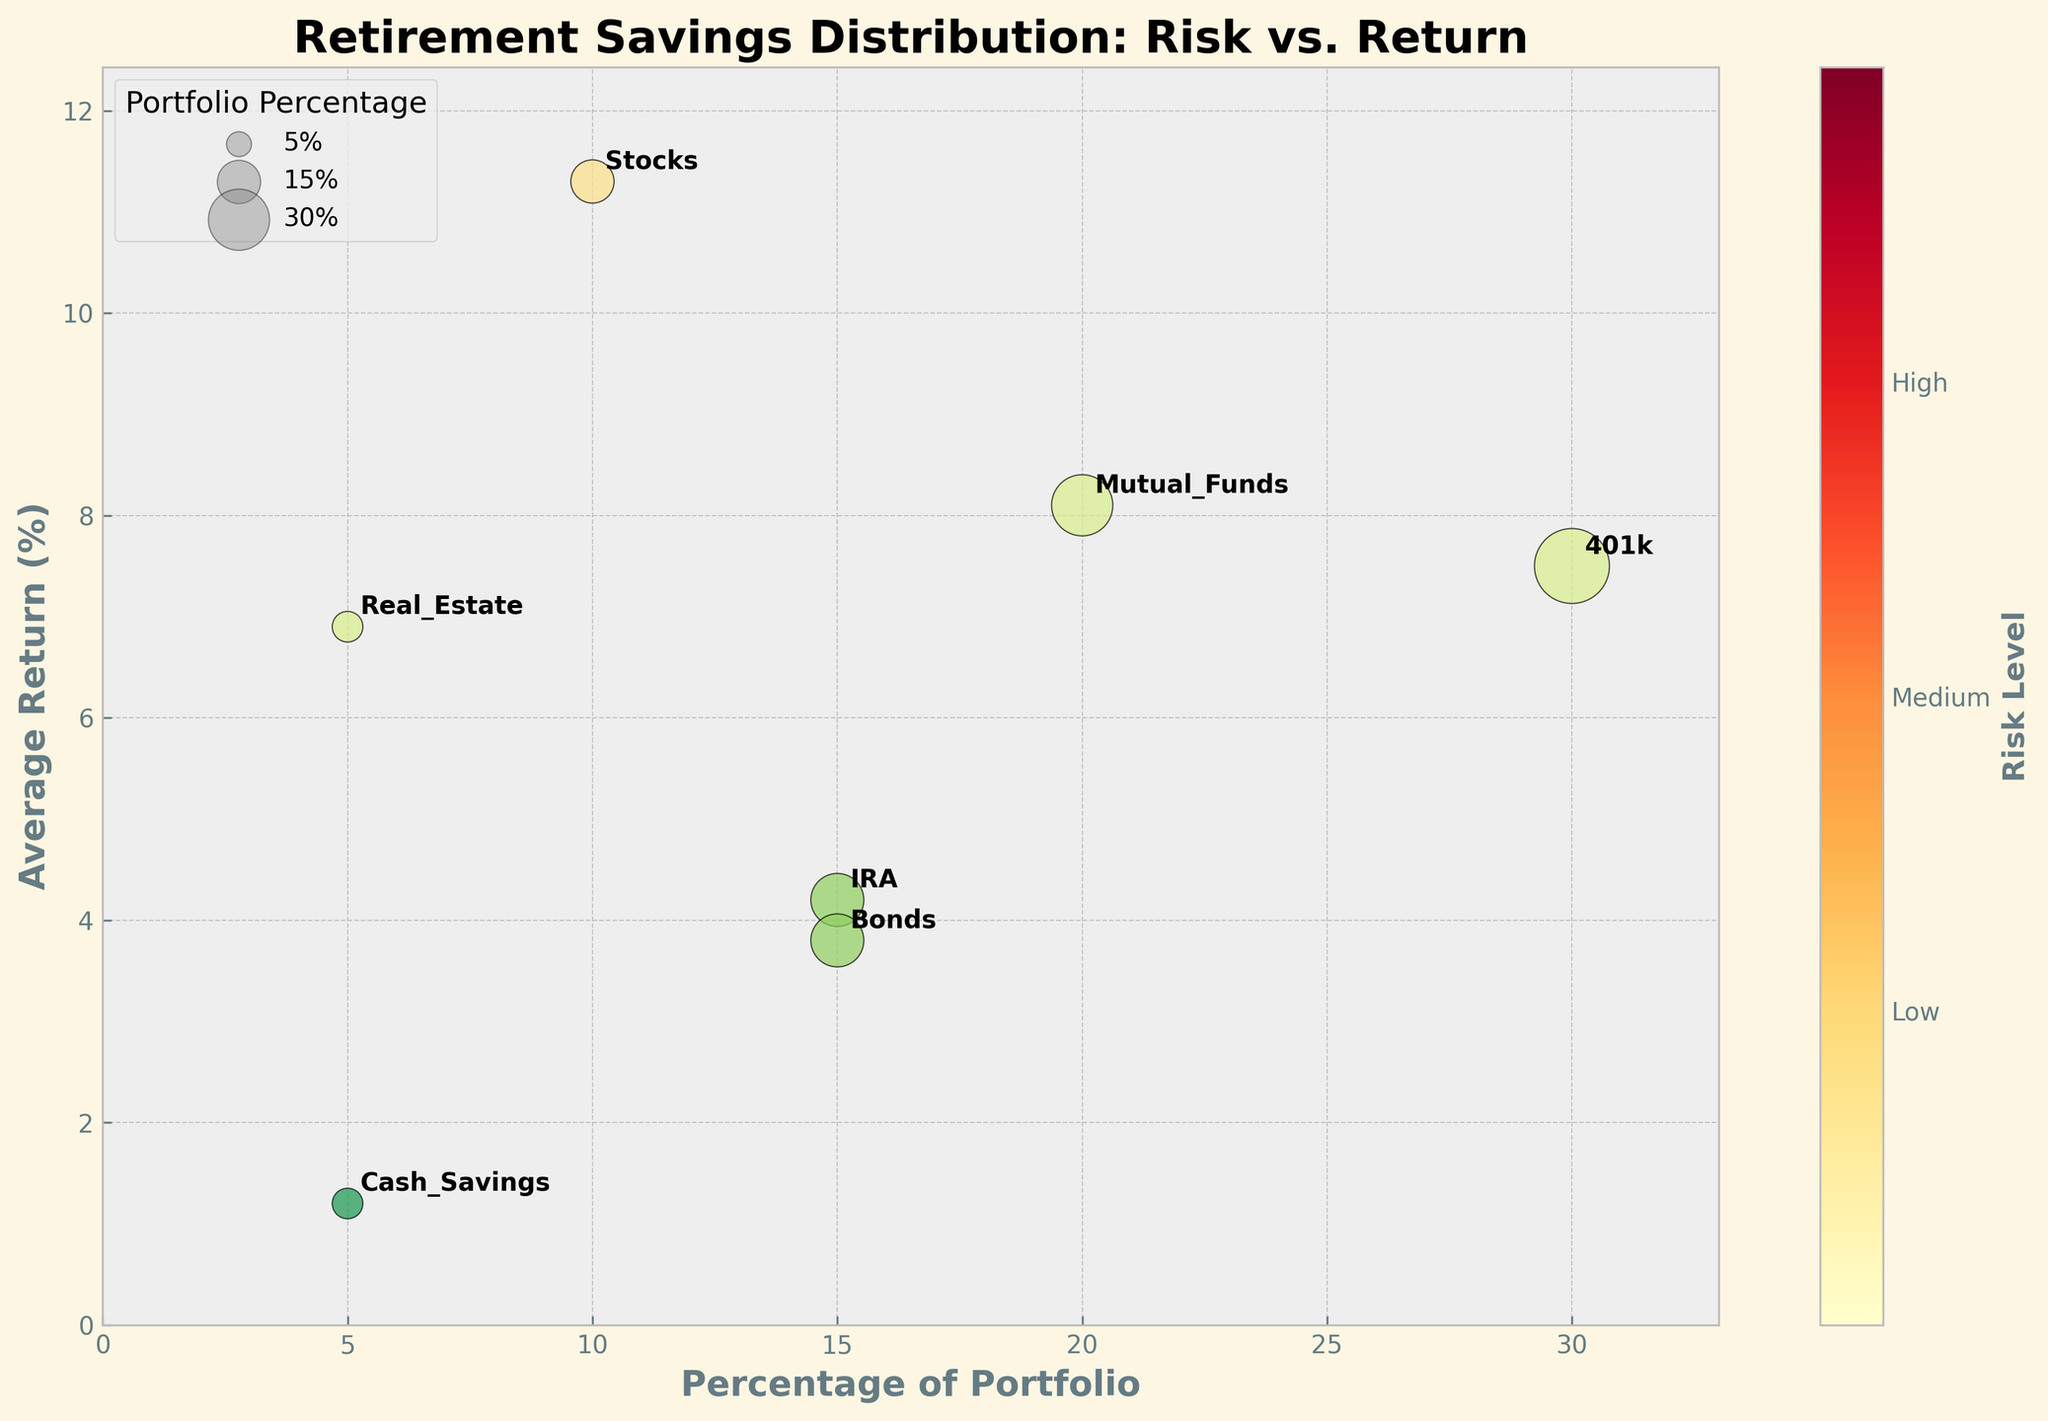Which investment type has the highest average return? The figure shows that Stocks have the highest average return at 11.3%.
Answer: Stocks What color represents low-risk investments in the plot? The color representing low-risk investments in the plot is light green.
Answer: Light green How many investment types are shown in the plot? The plot contains seven different investment types: 401k, IRA, Mutual Funds, Stocks, Bonds, Real Estate, and Cash Savings.
Answer: Seven What is the title of the plot? The title of the plot is "Retirement Savings Distribution: Risk vs. Return."
Answer: Retirement Savings Distribution: Risk vs. Return Which investment type has the largest percentage of the portfolio, and what is that percentage? The 401k investment type has the largest percentage of the portfolio at 30%.
Answer: 401k, 30% Comparing Cash Savings and Stocks, which one has a higher average return and by how much? Cash Savings has an average return of 1.2%, while Stocks have an average return of 11.3%. The difference is 11.3% - 1.2% = 10.1%.
Answer: Stocks, 10.1% What is the range of average returns represented in the plot? The lowest average return is for Cash Savings (1.2%) and the highest is for Stocks (11.3%). Therefore, the range is 11.3% - 1.2% = 10.1%.
Answer: 10.1% How are different risk levels visually represented in the plot? Different risk levels are represented by different colors in the plot.
Answer: Different colors What is the combined percentage of the portfolio for IRA and Bonds? The IRA constitutes 15% and Bonds also constitute 15%, so combined, they contribute 15% + 15% = 30% of the portfolio.
Answer: 30% Which investment has a medium risk level and also a percentage of 5% in the portfolio? The investment type with a medium risk level and a 5% portfolio percentage is Real Estate.
Answer: Real Estate 